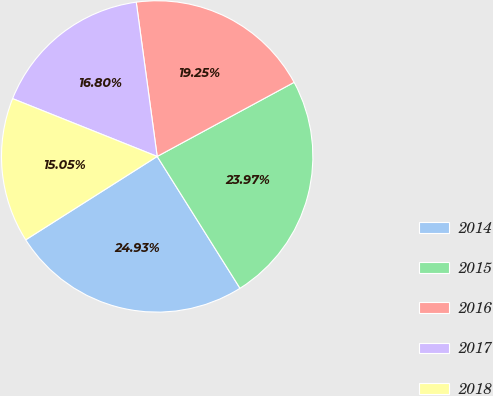<chart> <loc_0><loc_0><loc_500><loc_500><pie_chart><fcel>2014<fcel>2015<fcel>2016<fcel>2017<fcel>2018<nl><fcel>24.93%<fcel>23.97%<fcel>19.25%<fcel>16.8%<fcel>15.05%<nl></chart> 